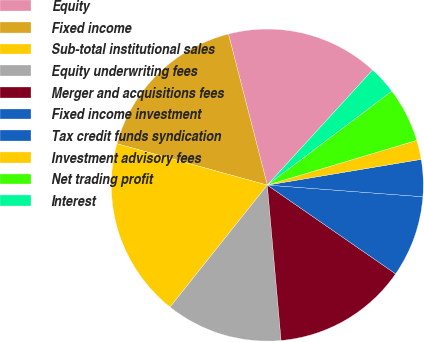Convert chart. <chart><loc_0><loc_0><loc_500><loc_500><pie_chart><fcel>Equity<fcel>Fixed income<fcel>Sub-total institutional sales<fcel>Equity underwriting fees<fcel>Merger and acquisitions fees<fcel>Fixed income investment<fcel>Tax credit funds syndication<fcel>Investment advisory fees<fcel>Net trading profit<fcel>Interest<nl><fcel>15.8%<fcel>16.72%<fcel>18.56%<fcel>12.12%<fcel>13.96%<fcel>8.44%<fcel>3.83%<fcel>1.99%<fcel>5.67%<fcel>2.91%<nl></chart> 